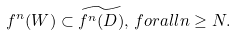<formula> <loc_0><loc_0><loc_500><loc_500>f ^ { n } ( W ) \subset \widetilde { f ^ { n } ( D ) } , \, f o r a l l n \geq N .</formula> 